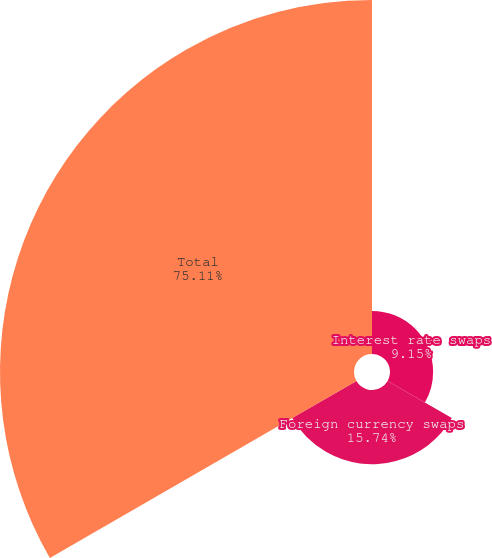<chart> <loc_0><loc_0><loc_500><loc_500><pie_chart><fcel>Interest rate swaps<fcel>Foreign currency swaps<fcel>Total<nl><fcel>9.15%<fcel>15.74%<fcel>75.11%<nl></chart> 